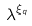<formula> <loc_0><loc_0><loc_500><loc_500>\lambda ^ { \xi _ { q } }</formula> 